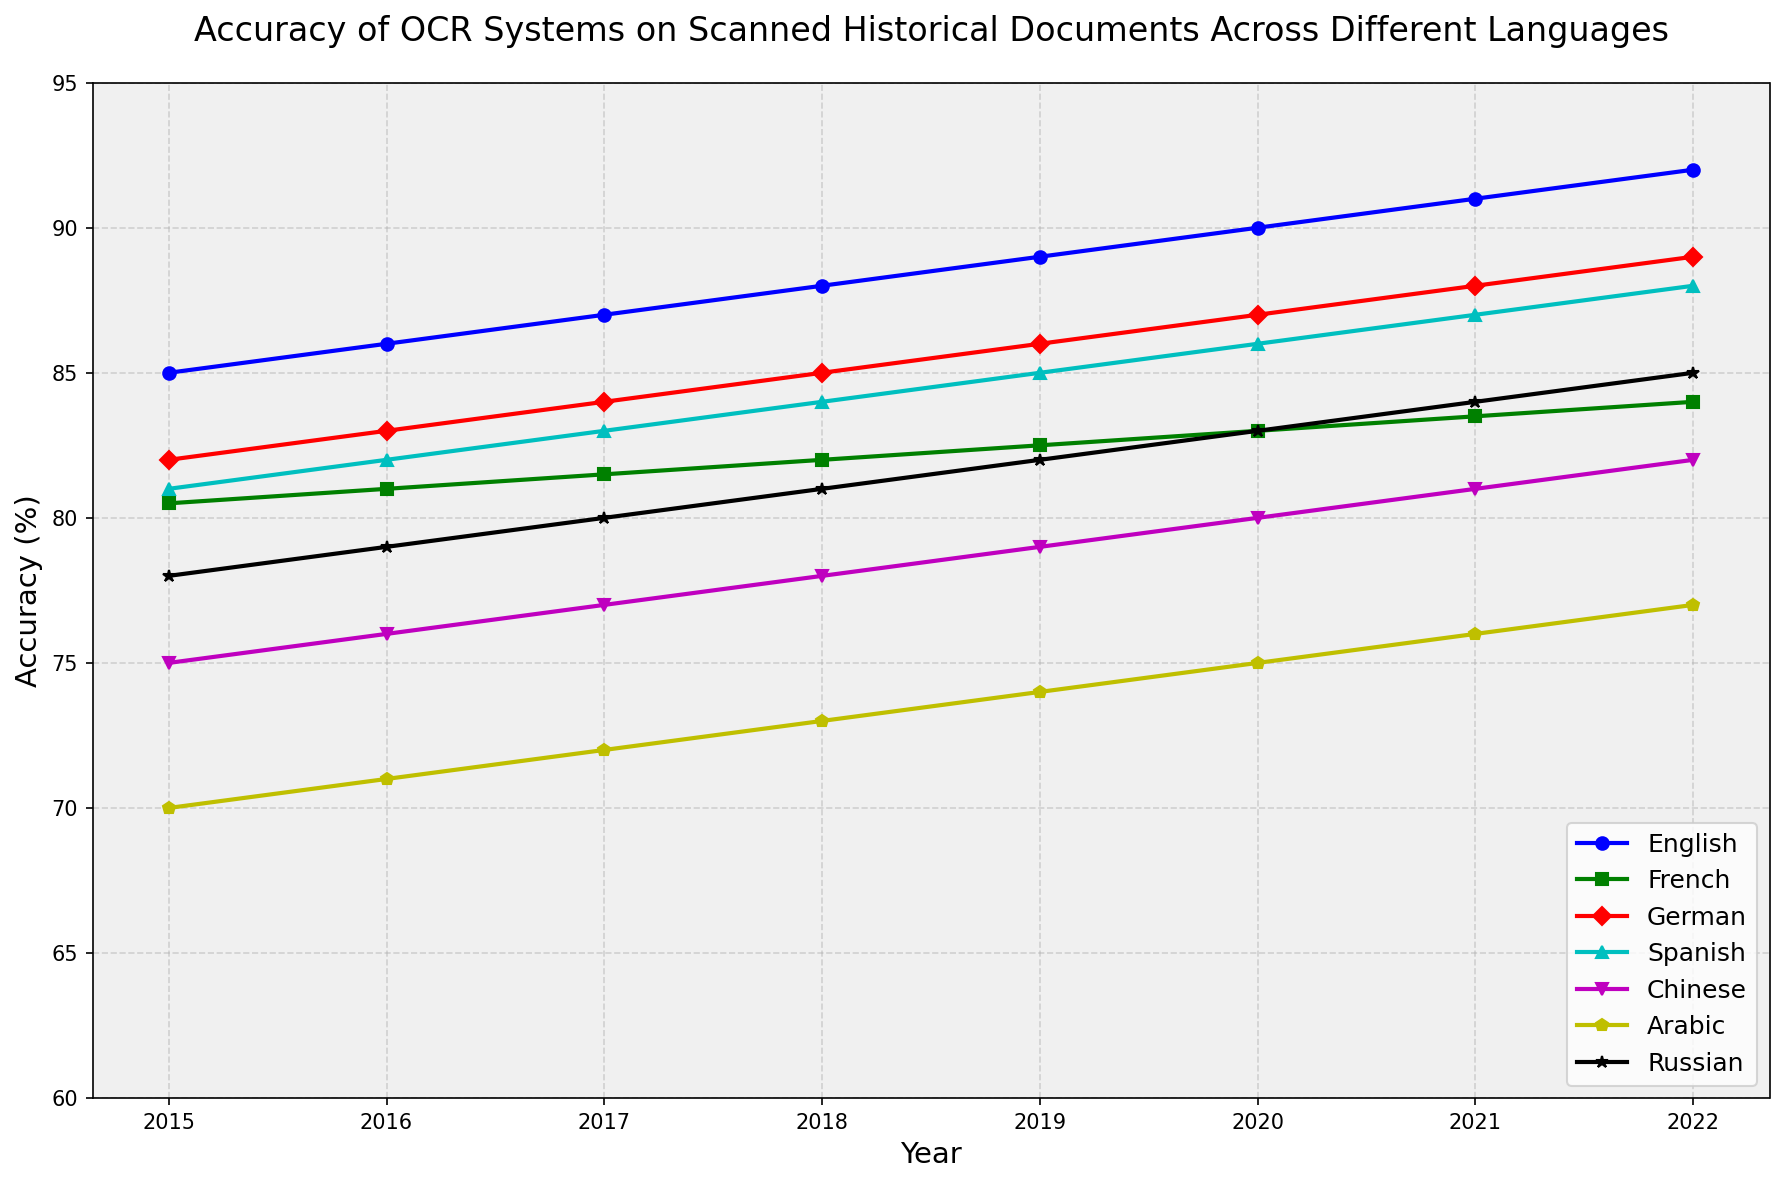what is the highest accuracy value for English OCR across all years? To find the highest accuracy value for English OCR, look at the plotted line for English and identify the peak value. The highest point on the English line is in 2022 with an accuracy of 92%.
Answer: 92% Between 2015 and 2022, which language shows the greatest increase in OCR accuracy? Calculate the difference in accuracy values from 2015 to 2022 for each language. English goes from 85.0 to 92.0 (7.0), French from 80.5 to 84.0 (3.5), German from 82.0 to 89.0 (7.0), Spanish from 81.0 to 88.0 (7.0), Chinese from 75.0 to 82.0 (7.0), Arabic from 70.0 to 77.0 (7.0), and Russian from 78.0 to 85.0 (7.0). All mentioned languages have increased by 7%.
Answer: English, German, Spanish, Chinese, Arabic, Russian In which year did Arabic OCR accuracy surpass 75% for the first time? Look along the Arabic accuracy line for the first year where the value is greater than 75%. The first occurrence is in 2020.
Answer: 2020 Which language had the lowest OCR accuracy in 2015? Identify the lowest plotted accuracy value for the year 2015. The lowest value is on the Arabic line with an accuracy of 70%.
Answer: Arabic Compare the OCR accuracy for Chinese and Russian in 2018. Which is greater and by how much? Find the accuracy values in 2018 for Chinese and Russian, which are 78.0% and 81.0%, respectively. The difference is 81.0% - 78.0% = 3.0%.
Answer: Russian, 3.0% Is the trend of OCR accuracy for French consistently increasing from 2015 to 2022? Check each yearly value for French to see if they are always higher than the previous year. The values from 2015 to 2022 (80.5, 81.0, 81.5, 82.0, 82.5, 83.0, 83.5, and 84.0) show a consistent increase each year.
Answer: Yes What is the average OCR accuracy for Spanish over the entire period? Sum the accuracy values for Spanish across all years and divide by the number of years. The values are 81.0, 82.0, 83.0, 84.0, 85.0, 86.0, 87.0, and 88.0. The sum is 676.0, and there are 8 years. The average is 676/8 = 84.5.
Answer: 84.5 Which language has the steepest growth in OCR accuracy from 2020 to 2022? Calculate the accuracy change from 2020 to 2022 for each language: English (92.0 - 90.0 = 2.0), French (84.0 - 83.0 = 1.0), German (89.0 - 87.0 = 2.0), Spanish (88.0 - 86.0 = 2.0), Chinese (82.0 - 80.0 = 2.0), Arabic (77.0 - 75.0 = 2.0), Russian (85.0 - 83.0 = 2.0). All languages have an increase of 2.0 except for French with 1.0.
Answer: Multiple languages with 2.0 In 2017, which language had OCR accuracy closest to 80% and what was the exact value? Compare the plotted values for 2017 with 80%: English (87.0), French (81.5), German (84.0), Spanish (83.0), Chinese (77.0), Arabic (72.0), Russian (80.0). Russian has the value closest to 80% with an exact value of 80.0.
Answer: Russian, 80.0 